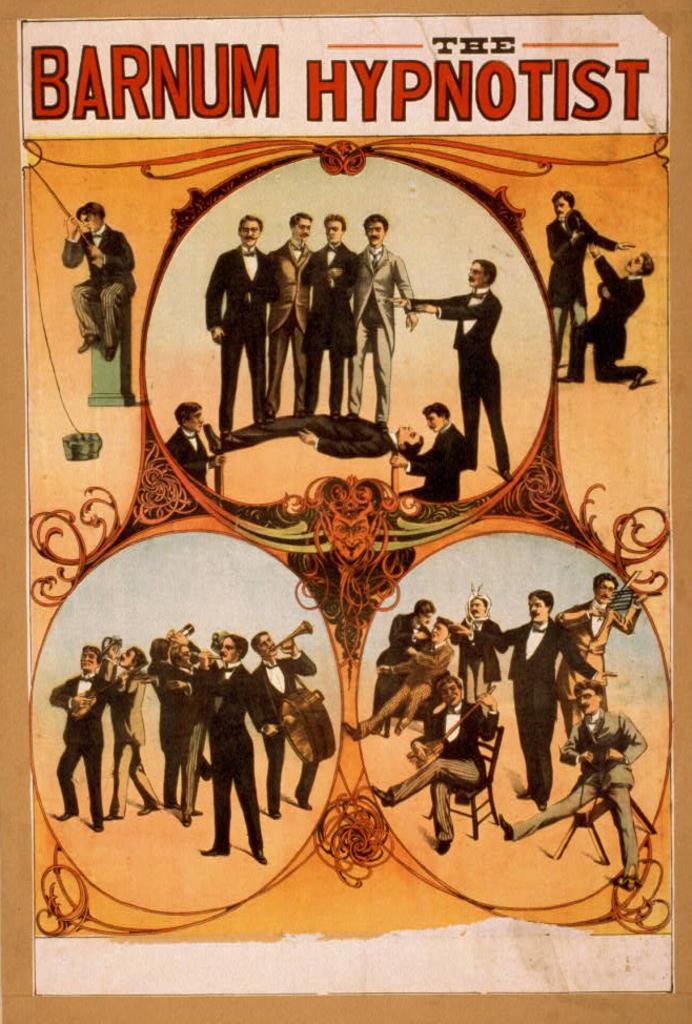What is the hypnotist?
Make the answer very short. Barnum. Who's name is in the top left corner?
Offer a terse response. Barnum. 